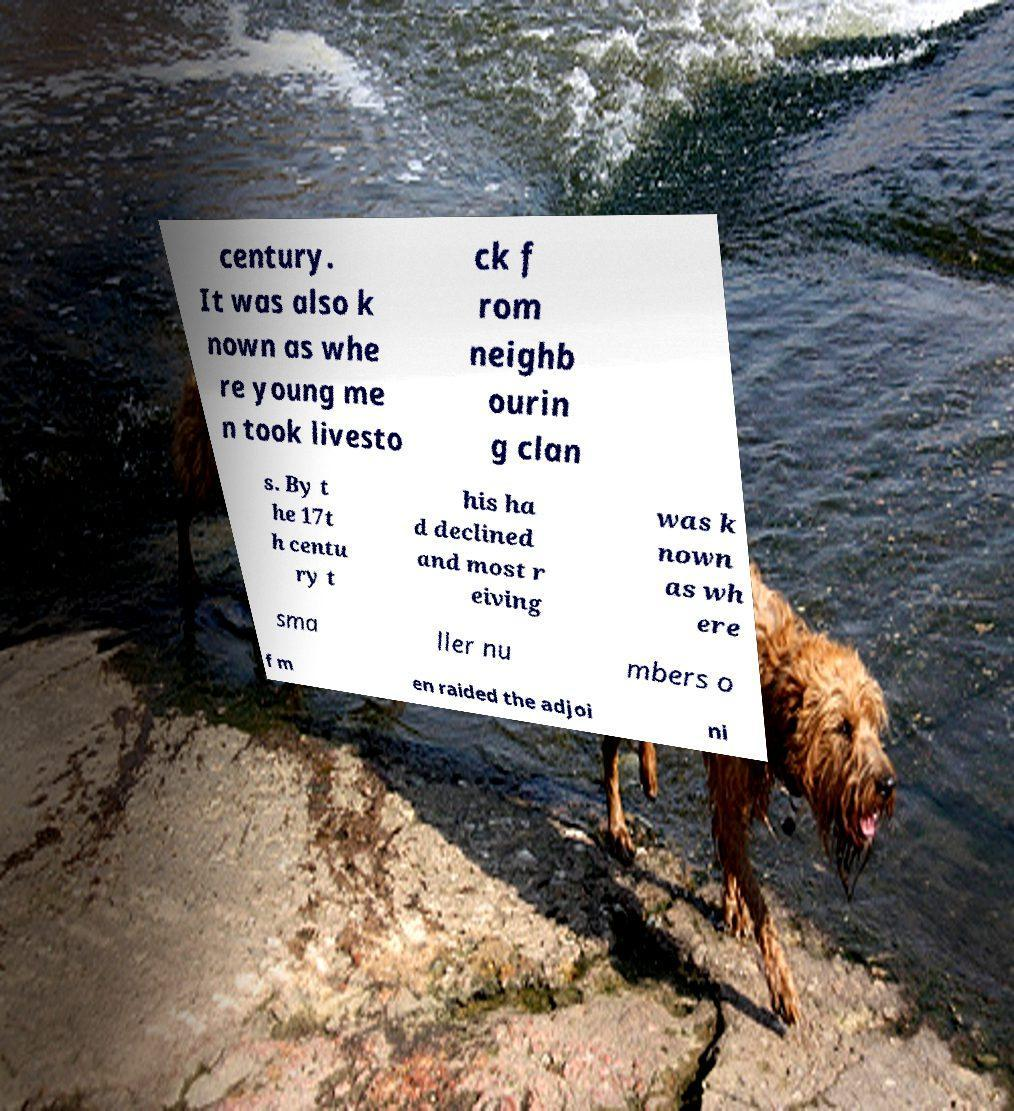Please identify and transcribe the text found in this image. century. It was also k nown as whe re young me n took livesto ck f rom neighb ourin g clan s. By t he 17t h centu ry t his ha d declined and most r eiving was k nown as wh ere sma ller nu mbers o f m en raided the adjoi ni 